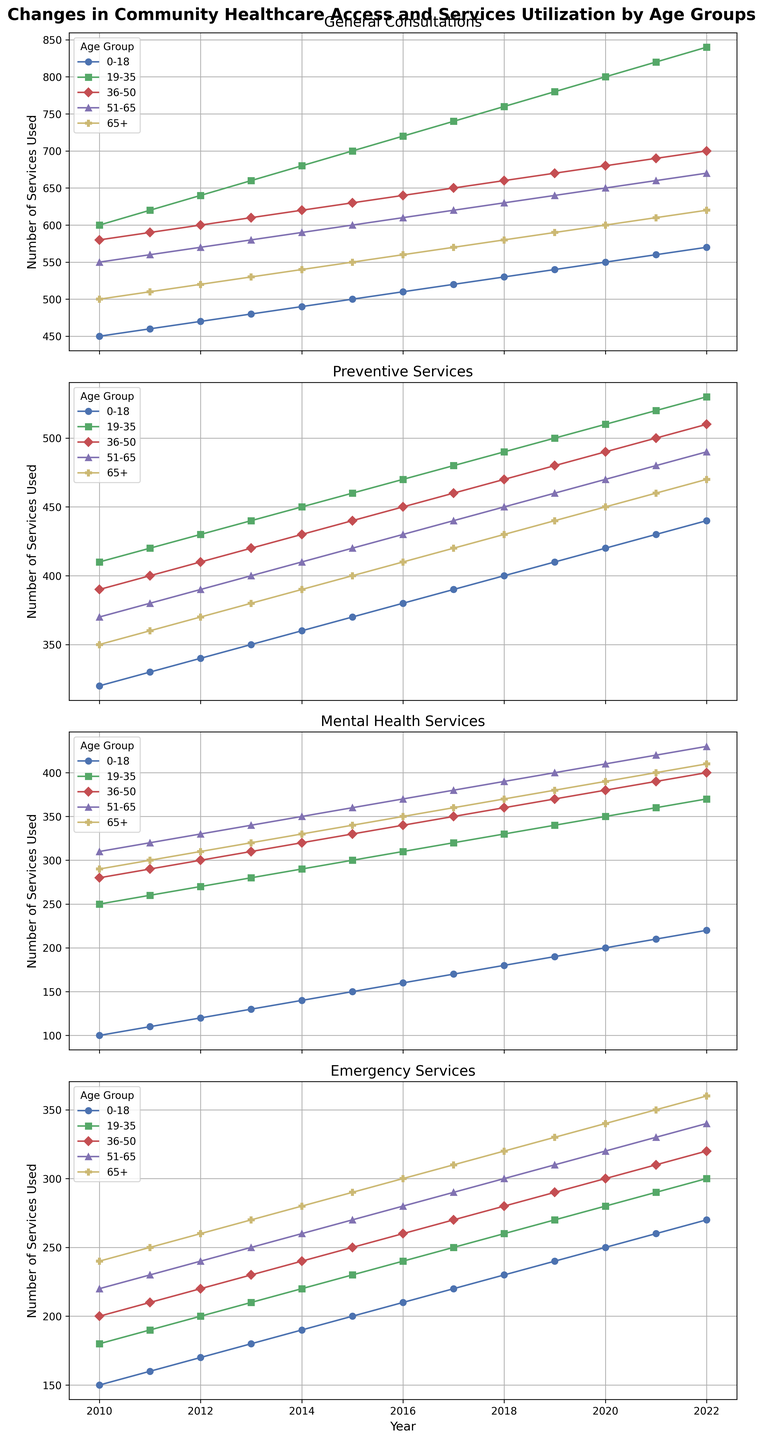What is the overall trend for General Consultations among the 0-18 age group from 2010 to 2022? To determine the trend, observe the line representing the 0-18 age group for General Consultations from 2010 to 2022. The line rises consistently, indicating an increase in the number of General Consultations over the years.
Answer: Increasing Which age group utilized the highest number of Preventive Services in 2022? Look for the highest point among the lines on the Preventive Services plot that corresponds to the year 2022. The 19-35 age group has the highest value.
Answer: 19-35 How did the number of Mental Health Services used by the 51-65 age group change between 2010 and 2022? Observe the specific line representing the 51-65 age group on the Mental Health Services plot. The line shows a steady increase from about 310 in 2010 to approximately 430 in 2022.
Answer: Increased Compare the number of Emergency Services utilized between the 0-18 and 65+ age groups in 2016. Which group utilized more? Find the points for both age groups on the Emergency Services plot for the year 2016. The 0-18 age group used 210 services, while the 65+ age group used 300 services. Therefore, the 65+ age group utilized more.
Answer: 65+ Calculate the overall increase in General Consultations from 2010 to 2022 for the 19-35 age group. Subtract the value for the 19-35 age group in 2010 from the value in 2022. The General Consultations number in 2010 is 600, and in 2022 it is 840. The increase is 840 - 600 = 240.
Answer: 240 Which service had the least increase for the 36-50 age group over the period from 2010 to 2022? Examine each plot for the 36-50 age group and measure the difference from 2010 to 2022. The smallest increase among the services is from Mental Health Services, which increased from 280 in 2010 to 400 in 2022, a difference of 120.
Answer: Mental Health Services Compare the slopes of the lines representing the 51-65 age group for Preventive Services and Emergency Services over the years. Which service shows a steeper increase? Analyze the angles of the lines for the 51-65 group in the Preventive Services and Emergency Services plots. The Emergency Services line shows a steeper increase, indicating a sharper rise over the years compared to Preventive Services.
Answer: Emergency Services What is the difference in the number of Preventive Services utilized by the 19-35 age group between 2018 and 2020? Find the points for 2018 and 2020 on the Preventive Services plot for the 19-35 age group. The numbers are 490 in 2018 and 510 in 2020. The difference is 510 - 490 = 20.
Answer: 20 Which age group shows the most significant fluctuation in the usage of Mental Health Services from 2010 to 2022? Look for the age group with the largest range (difference between maximum and minimum values) in the Mental Health Services plot. The 19-35 age group shows the most significant fluctuation, increasing from around 250 in 2010 to 370 in 2022, a difference of 120.
Answer: 19-35 Visualize the slope for General Consultations for the 65+ age group between 2010 and 2022. Is it steeper or gentler compared to the 19-35 age group? The slope of the 65+ age group’s line is visualized and compared to that of the 19-35 age group in the General Consultations plot. The 19-35 age group shows a steeper increase than the 65+ age group.
Answer: 19-35 group's slope is steeper 